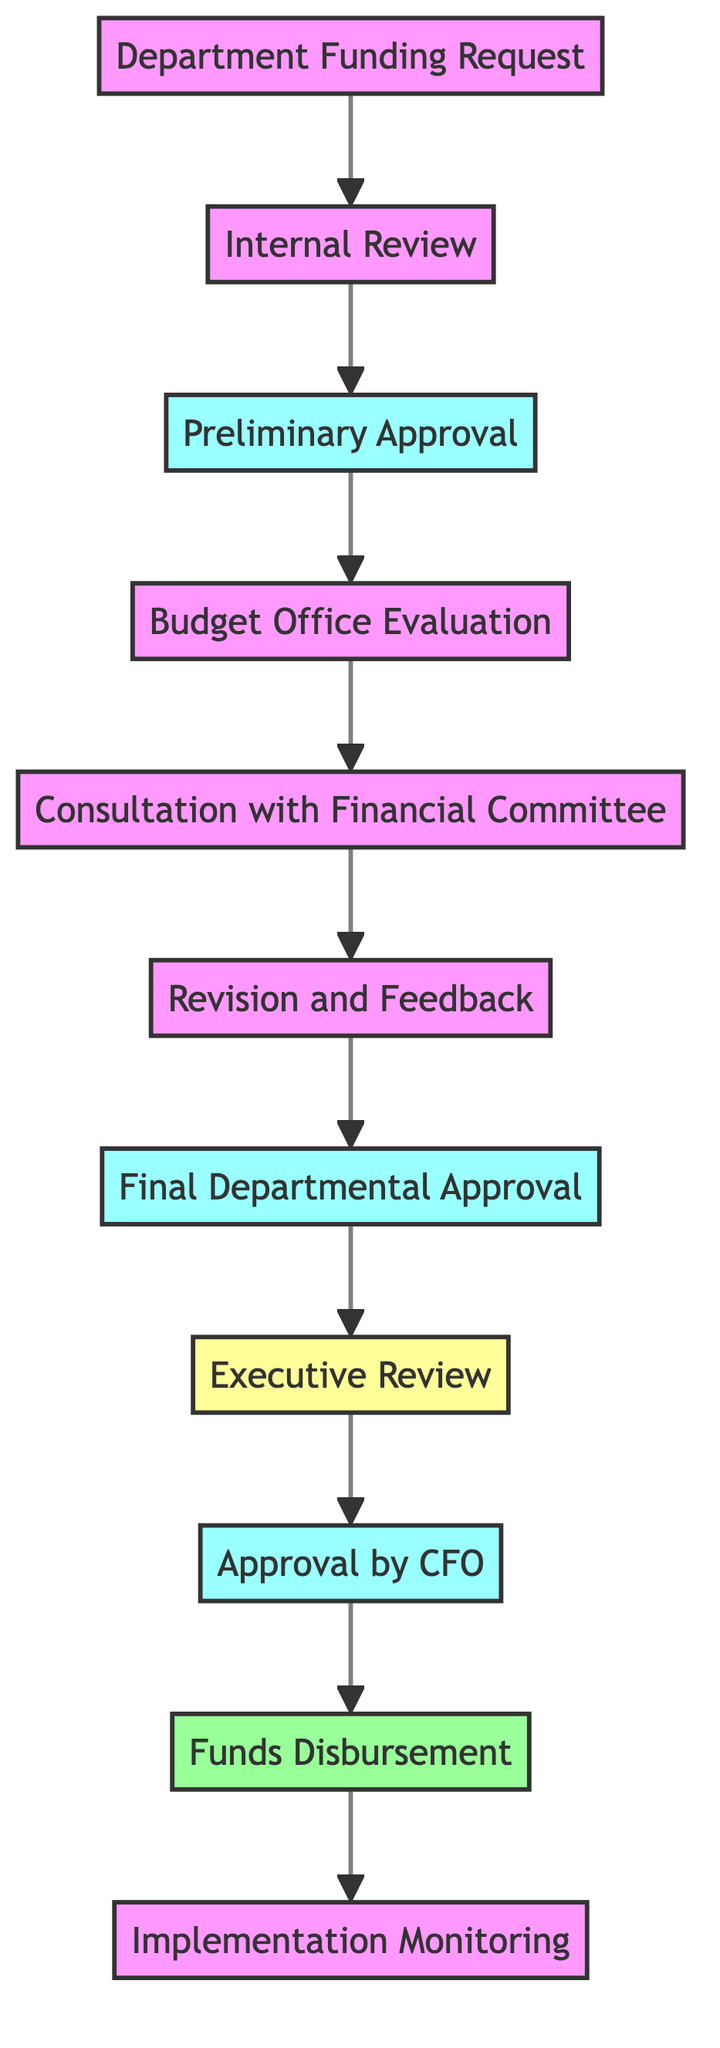what is the first step in the workflow? The first step, identified by node 1, is the "Department Funding Request" where the initiating department submits a funding request for budget allocation.
Answer: Department Funding Request how many total steps are in this workflow? By counting all nodes in the diagram, there are 11 steps from the initial request to the final monitoring of the implementation.
Answer: 11 which step follows the "Budget Office Evaluation"? Following the "Budget Office Evaluation" in the flowchart is the "Consultation with Financial Committee," indicating the next action after evaluation.
Answer: Consultation with Financial Committee what type of review does the "Executive Review" represent? The "Executive Review" is categorized as a review step in the workflow, which implies that it's an evaluation conducted by the executive team.
Answer: review which step receives final approval from the department? The "Final Departmental Approval" step is where the revised funding request receives final approval from the initiating department.
Answer: Final Departmental Approval which step involves consultation with another committee? The "Consultation with Financial Committee" step specifically involves discussing the request with the Financial Committee for alignment with strategic financial objectives.
Answer: Consultation with Financial Committee how many nodes are approval steps? There are three identified approval steps: "Preliminary Approval", "Final Departmental Approval", and "Approval by CFO", indicating a total of three approval stages in the process.
Answer: 3 what happens after the "Funds Disbursement"? After "Funds Disbursement", the process concludes with "Implementation Monitoring," ensuring that the allocated funds are used effectively.
Answer: Implementation Monitoring which node directly connects to the "Treasury" for fund allocation? The "Funds Disbursement" node directly connects to the Treasury, indicating that this is the stage where the treasury releases the allocated funds.
Answer: Funds Disbursement which node has the primary responsibility for evaluating fiscal compliance? The "Budget Office Evaluation" node is responsible for assessing the funding request to ensure compliance with overall fiscal policy and available funds.
Answer: Budget Office Evaluation 